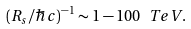<formula> <loc_0><loc_0><loc_500><loc_500>( R _ { s } / \hbar { c } ) ^ { - 1 } \sim 1 - 1 0 0 \ T e V .</formula> 